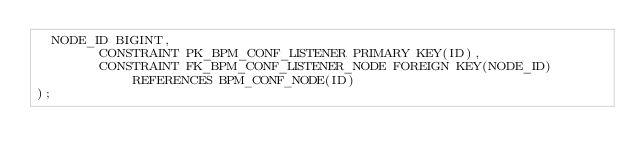<code> <loc_0><loc_0><loc_500><loc_500><_SQL_>	NODE_ID BIGINT,
        CONSTRAINT PK_BPM_CONF_LISTENER PRIMARY KEY(ID),
        CONSTRAINT FK_BPM_CONF_LISTENER_NODE FOREIGN KEY(NODE_ID) REFERENCES BPM_CONF_NODE(ID)
);

</code> 